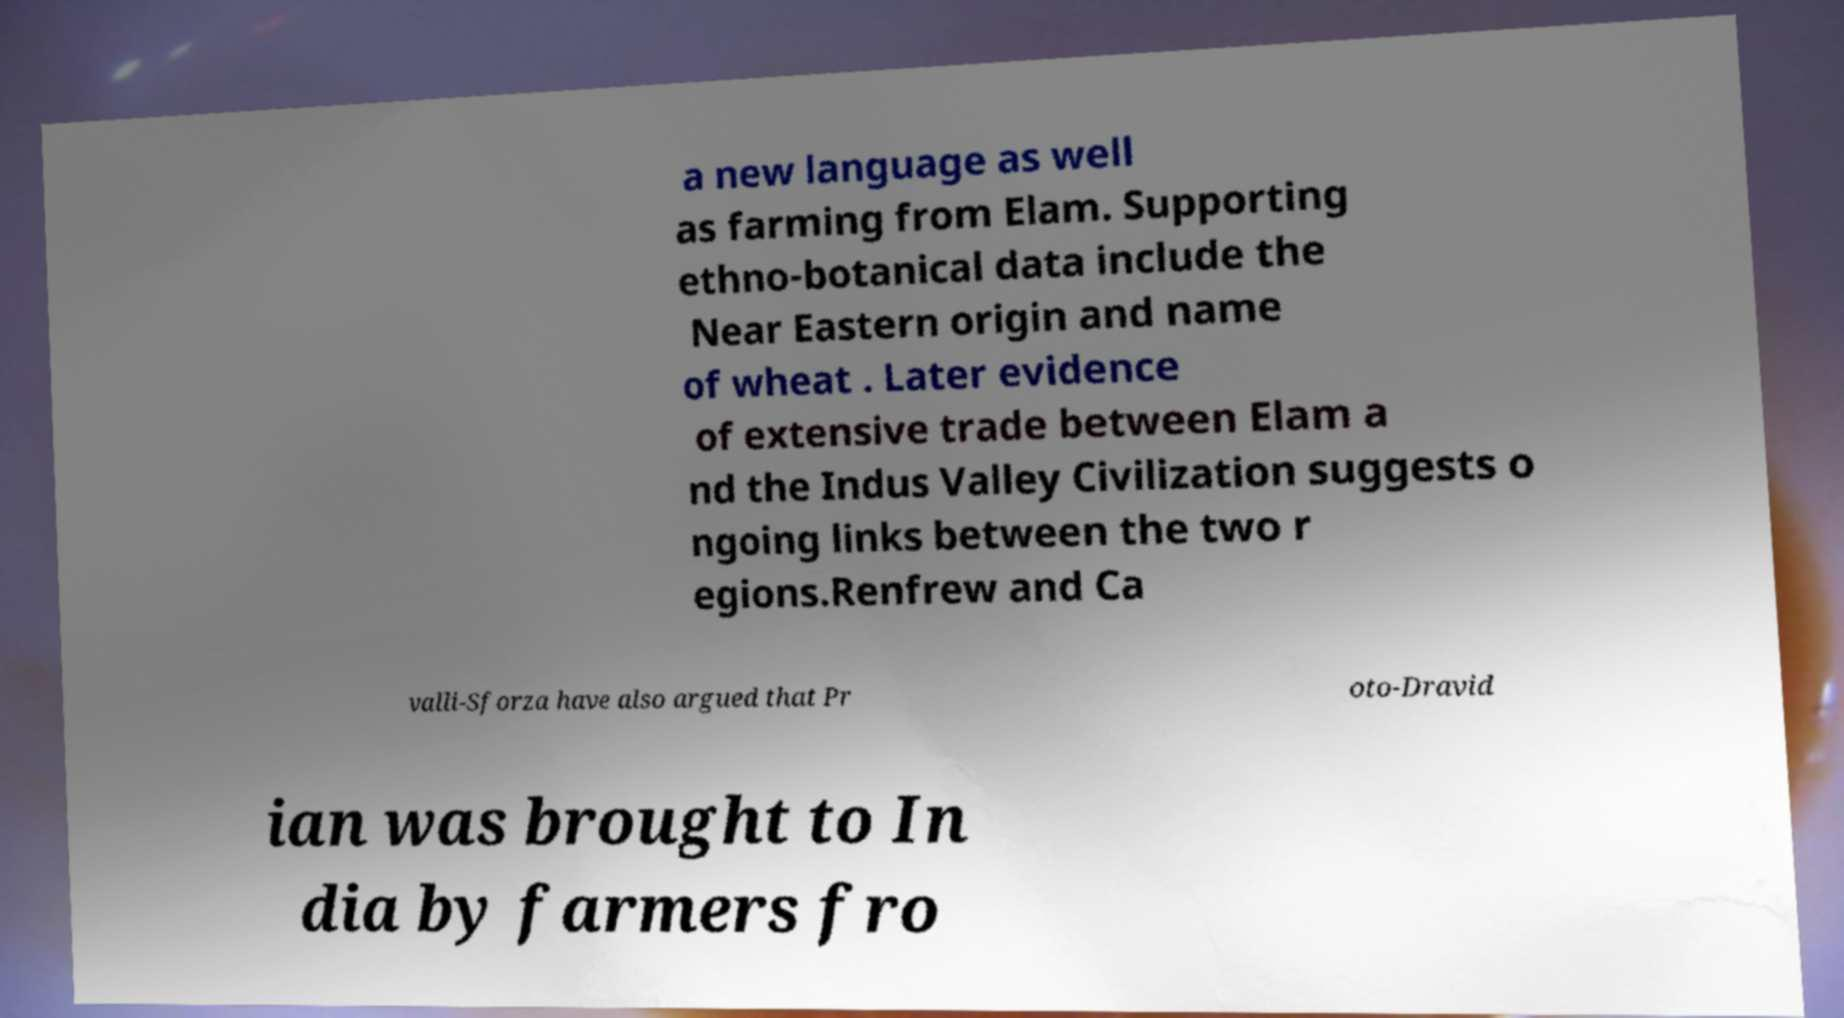Can you accurately transcribe the text from the provided image for me? a new language as well as farming from Elam. Supporting ethno-botanical data include the Near Eastern origin and name of wheat . Later evidence of extensive trade between Elam a nd the Indus Valley Civilization suggests o ngoing links between the two r egions.Renfrew and Ca valli-Sforza have also argued that Pr oto-Dravid ian was brought to In dia by farmers fro 